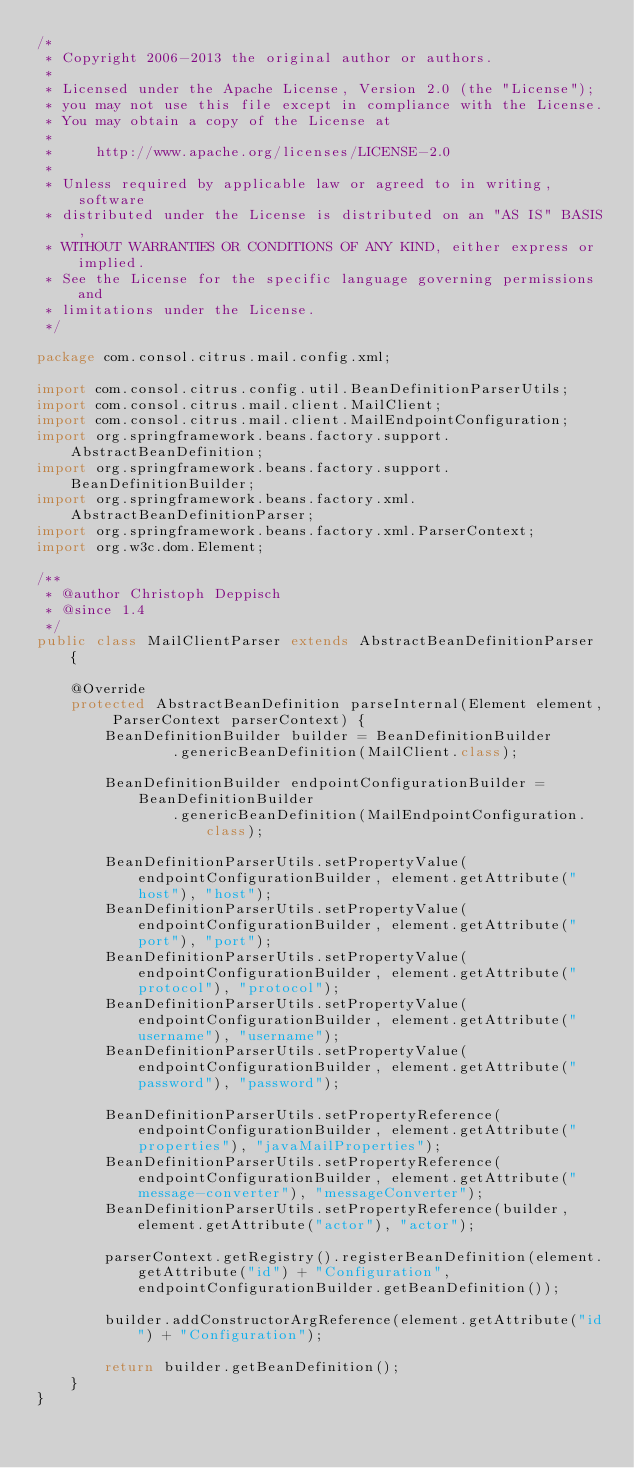Convert code to text. <code><loc_0><loc_0><loc_500><loc_500><_Java_>/*
 * Copyright 2006-2013 the original author or authors.
 *
 * Licensed under the Apache License, Version 2.0 (the "License");
 * you may not use this file except in compliance with the License.
 * You may obtain a copy of the License at
 *
 *     http://www.apache.org/licenses/LICENSE-2.0
 *
 * Unless required by applicable law or agreed to in writing, software
 * distributed under the License is distributed on an "AS IS" BASIS,
 * WITHOUT WARRANTIES OR CONDITIONS OF ANY KIND, either express or implied.
 * See the License for the specific language governing permissions and
 * limitations under the License.
 */

package com.consol.citrus.mail.config.xml;

import com.consol.citrus.config.util.BeanDefinitionParserUtils;
import com.consol.citrus.mail.client.MailClient;
import com.consol.citrus.mail.client.MailEndpointConfiguration;
import org.springframework.beans.factory.support.AbstractBeanDefinition;
import org.springframework.beans.factory.support.BeanDefinitionBuilder;
import org.springframework.beans.factory.xml.AbstractBeanDefinitionParser;
import org.springframework.beans.factory.xml.ParserContext;
import org.w3c.dom.Element;

/**
 * @author Christoph Deppisch
 * @since 1.4
 */
public class MailClientParser extends AbstractBeanDefinitionParser {

    @Override
    protected AbstractBeanDefinition parseInternal(Element element, ParserContext parserContext) {
        BeanDefinitionBuilder builder = BeanDefinitionBuilder
                .genericBeanDefinition(MailClient.class);

        BeanDefinitionBuilder endpointConfigurationBuilder = BeanDefinitionBuilder
                .genericBeanDefinition(MailEndpointConfiguration.class);

        BeanDefinitionParserUtils.setPropertyValue(endpointConfigurationBuilder, element.getAttribute("host"), "host");
        BeanDefinitionParserUtils.setPropertyValue(endpointConfigurationBuilder, element.getAttribute("port"), "port");
        BeanDefinitionParserUtils.setPropertyValue(endpointConfigurationBuilder, element.getAttribute("protocol"), "protocol");
        BeanDefinitionParserUtils.setPropertyValue(endpointConfigurationBuilder, element.getAttribute("username"), "username");
        BeanDefinitionParserUtils.setPropertyValue(endpointConfigurationBuilder, element.getAttribute("password"), "password");

        BeanDefinitionParserUtils.setPropertyReference(endpointConfigurationBuilder, element.getAttribute("properties"), "javaMailProperties");
        BeanDefinitionParserUtils.setPropertyReference(endpointConfigurationBuilder, element.getAttribute("message-converter"), "messageConverter");
        BeanDefinitionParserUtils.setPropertyReference(builder, element.getAttribute("actor"), "actor");

        parserContext.getRegistry().registerBeanDefinition(element.getAttribute("id") + "Configuration", endpointConfigurationBuilder.getBeanDefinition());

        builder.addConstructorArgReference(element.getAttribute("id") + "Configuration");

        return builder.getBeanDefinition();
    }
}
</code> 